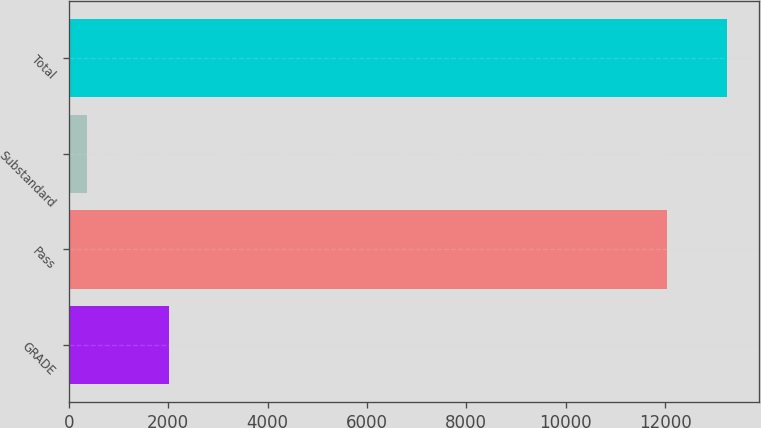<chart> <loc_0><loc_0><loc_500><loc_500><bar_chart><fcel>GRADE<fcel>Pass<fcel>Substandard<fcel>Total<nl><fcel>2012<fcel>12035<fcel>359<fcel>13238.5<nl></chart> 